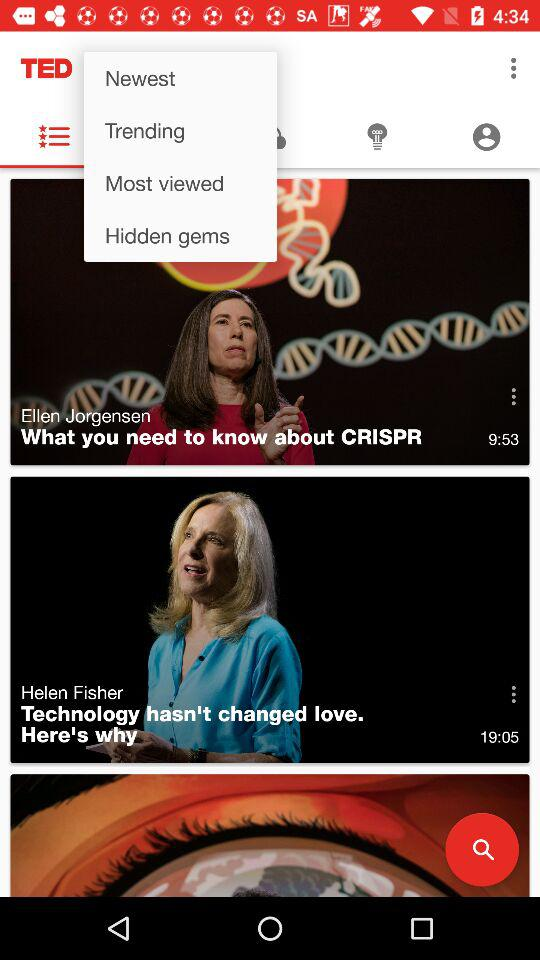What is the duration of the video by Ellen Jorgensen? The duration of the video by Ellen Jorgensen is 9 minutes and 53 seconds. 